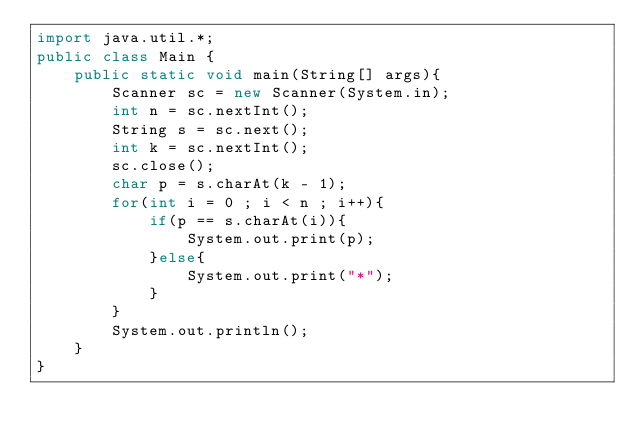<code> <loc_0><loc_0><loc_500><loc_500><_Java_>import java.util.*;
public class Main {
    public static void main(String[] args){
        Scanner sc = new Scanner(System.in);
        int n = sc.nextInt();
        String s = sc.next();
        int k = sc.nextInt();
        sc.close();
        char p = s.charAt(k - 1);
        for(int i = 0 ; i < n ; i++){
            if(p == s.charAt(i)){
                System.out.print(p);
            }else{
                System.out.print("*");
            }
        }
        System.out.println();
    }
}</code> 